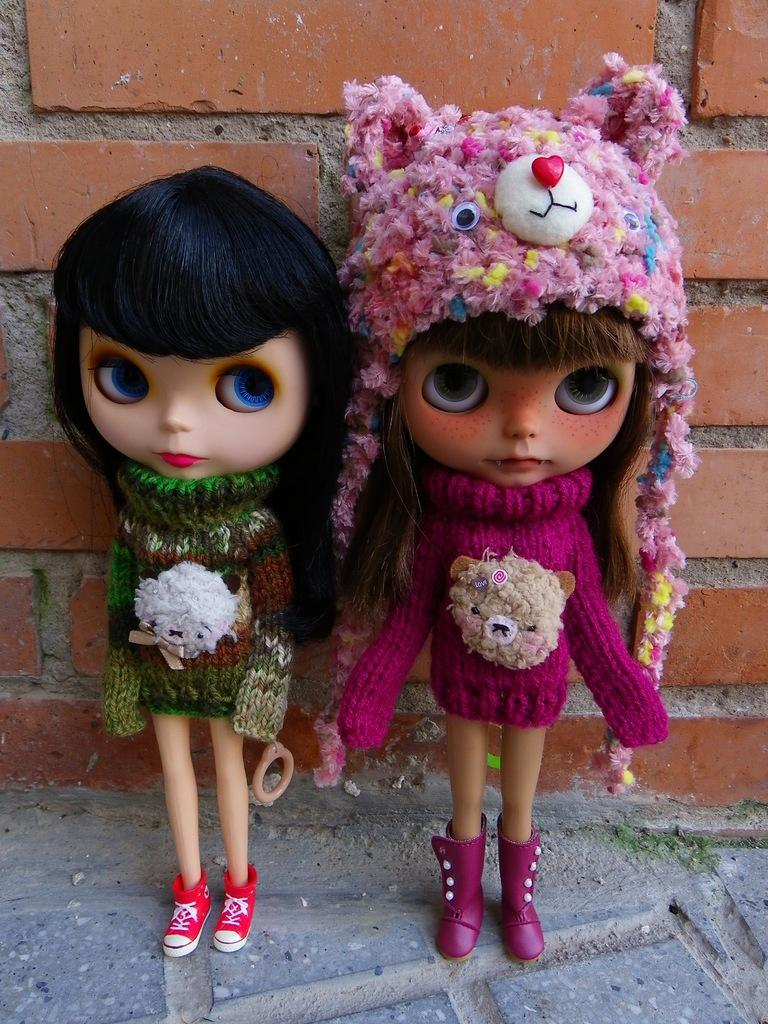How many dolls are present in the image? There are two dolls in the image. Where are the dolls located? The dolls are on a surface. What can be seen in the background of the image? There is a brick wall in the background of the image. Is the grandfather sitting on the stage with the dolls in the image? There is no grandfather or stage present in the image; it only features two dolls on a surface with a brick wall in the background. 